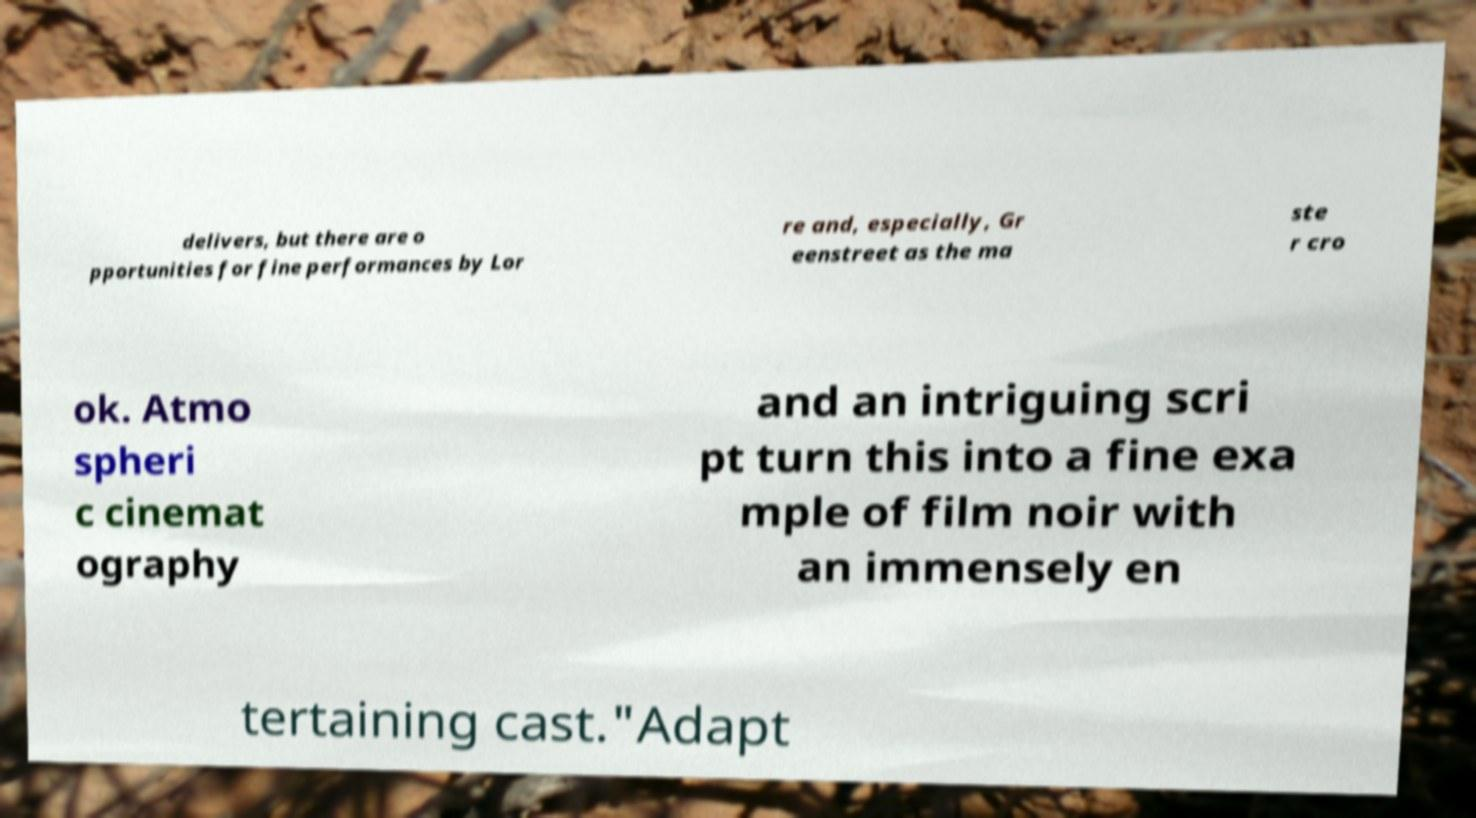Please read and relay the text visible in this image. What does it say? delivers, but there are o pportunities for fine performances by Lor re and, especially, Gr eenstreet as the ma ste r cro ok. Atmo spheri c cinemat ography and an intriguing scri pt turn this into a fine exa mple of film noir with an immensely en tertaining cast."Adapt 